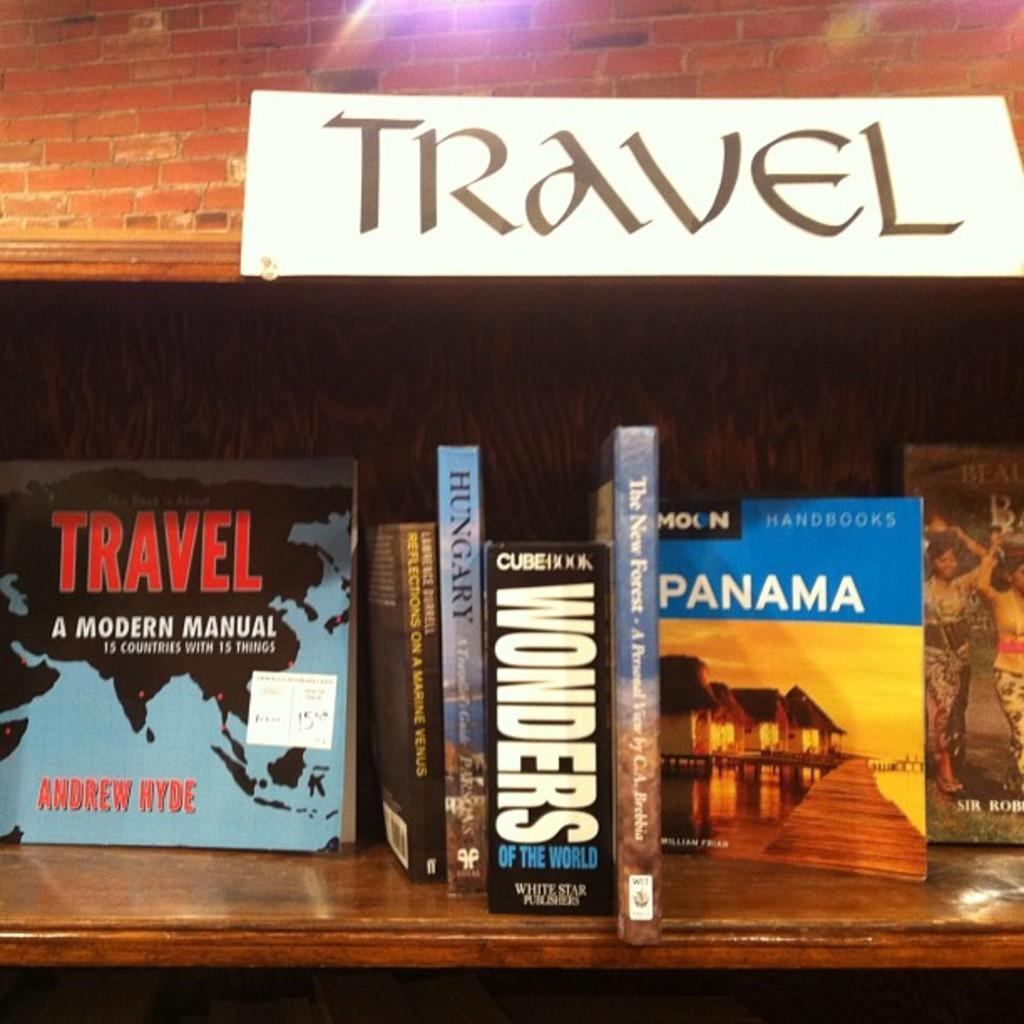<image>
Describe the image concisely. The white sign above the books lets you know your in the travel section 